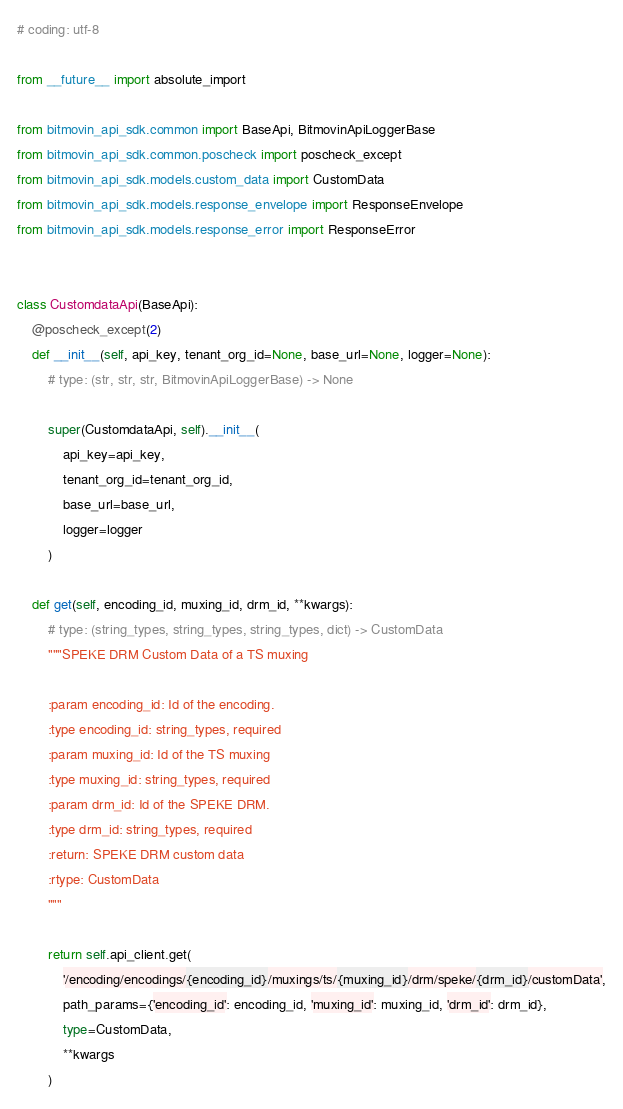Convert code to text. <code><loc_0><loc_0><loc_500><loc_500><_Python_># coding: utf-8

from __future__ import absolute_import

from bitmovin_api_sdk.common import BaseApi, BitmovinApiLoggerBase
from bitmovin_api_sdk.common.poscheck import poscheck_except
from bitmovin_api_sdk.models.custom_data import CustomData
from bitmovin_api_sdk.models.response_envelope import ResponseEnvelope
from bitmovin_api_sdk.models.response_error import ResponseError


class CustomdataApi(BaseApi):
    @poscheck_except(2)
    def __init__(self, api_key, tenant_org_id=None, base_url=None, logger=None):
        # type: (str, str, str, BitmovinApiLoggerBase) -> None

        super(CustomdataApi, self).__init__(
            api_key=api_key,
            tenant_org_id=tenant_org_id,
            base_url=base_url,
            logger=logger
        )

    def get(self, encoding_id, muxing_id, drm_id, **kwargs):
        # type: (string_types, string_types, string_types, dict) -> CustomData
        """SPEKE DRM Custom Data of a TS muxing

        :param encoding_id: Id of the encoding.
        :type encoding_id: string_types, required
        :param muxing_id: Id of the TS muxing
        :type muxing_id: string_types, required
        :param drm_id: Id of the SPEKE DRM.
        :type drm_id: string_types, required
        :return: SPEKE DRM custom data
        :rtype: CustomData
        """

        return self.api_client.get(
            '/encoding/encodings/{encoding_id}/muxings/ts/{muxing_id}/drm/speke/{drm_id}/customData',
            path_params={'encoding_id': encoding_id, 'muxing_id': muxing_id, 'drm_id': drm_id},
            type=CustomData,
            **kwargs
        )
</code> 